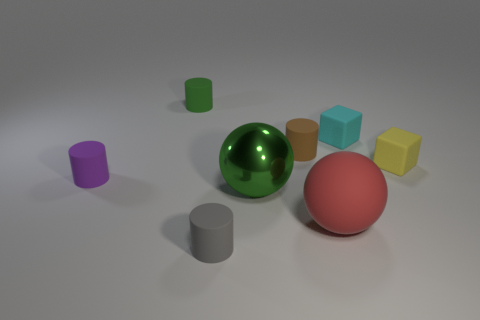What number of other things are the same shape as the cyan object?
Make the answer very short. 1. How many green objects are behind the yellow object?
Your answer should be compact. 1. Are there fewer rubber spheres behind the yellow object than tiny yellow cubes to the left of the purple cylinder?
Your response must be concise. No. What is the shape of the green object that is left of the green object that is in front of the small yellow matte cube that is in front of the tiny brown cylinder?
Ensure brevity in your answer.  Cylinder. What shape is the thing that is both to the left of the large rubber sphere and right of the large green metal object?
Your response must be concise. Cylinder. Is there a red thing that has the same material as the purple object?
Your response must be concise. Yes. What is the size of the cylinder that is the same color as the big metal ball?
Your response must be concise. Small. What color is the tiny object that is in front of the green shiny object?
Provide a succinct answer. Gray. There is a small purple rubber thing; does it have the same shape as the small object that is in front of the big red sphere?
Make the answer very short. Yes. Are there any things that have the same color as the big metal ball?
Ensure brevity in your answer.  Yes. 